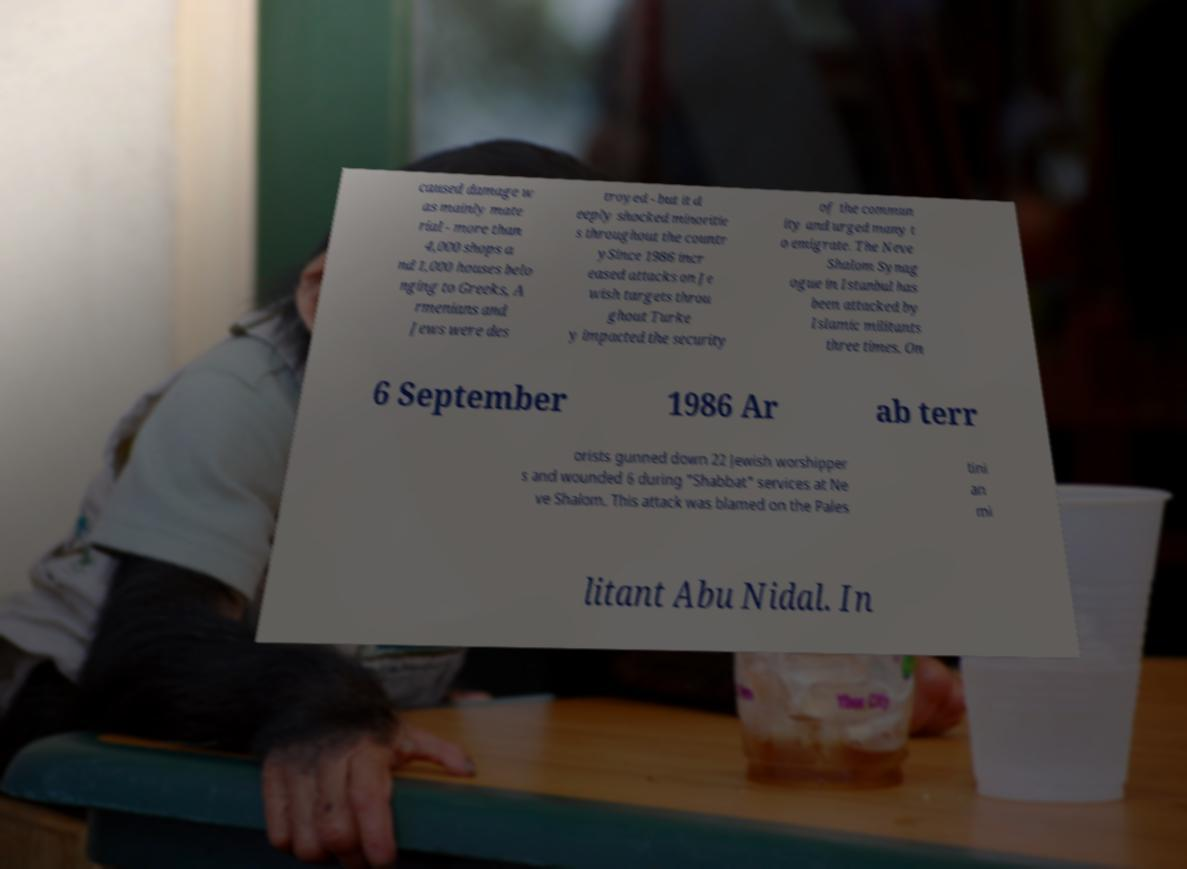Could you extract and type out the text from this image? caused damage w as mainly mate rial - more than 4,000 shops a nd 1,000 houses belo nging to Greeks, A rmenians and Jews were des troyed - but it d eeply shocked minoritie s throughout the countr ySince 1986 incr eased attacks on Je wish targets throu ghout Turke y impacted the security of the commun ity and urged many t o emigrate. The Neve Shalom Synag ogue in Istanbul has been attacked by Islamic militants three times. On 6 September 1986 Ar ab terr orists gunned down 22 Jewish worshipper s and wounded 6 during "Shabbat" services at Ne ve Shalom. This attack was blamed on the Pales tini an mi litant Abu Nidal. In 